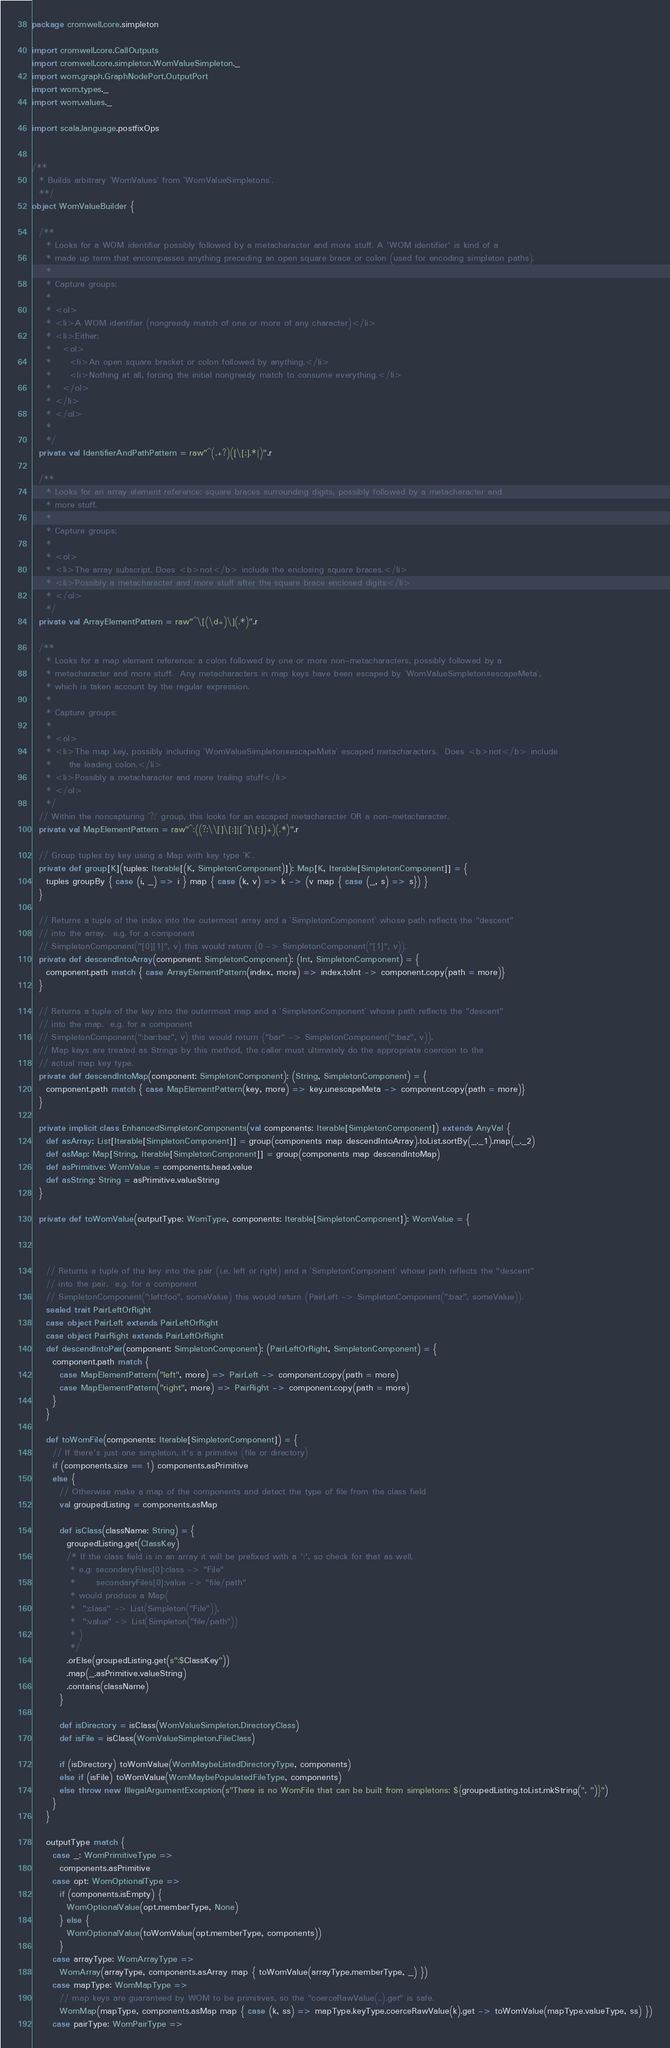<code> <loc_0><loc_0><loc_500><loc_500><_Scala_>package cromwell.core.simpleton

import cromwell.core.CallOutputs
import cromwell.core.simpleton.WomValueSimpleton._
import wom.graph.GraphNodePort.OutputPort
import wom.types._
import wom.values._

import scala.language.postfixOps


/**
  * Builds arbitrary `WomValues` from `WomValueSimpletons`.
  **/
object WomValueBuilder {

  /**
    * Looks for a WOM identifier possibly followed by a metacharacter and more stuff. A 'WOM identifier' is kind of a
    * made up term that encompasses anything preceding an open square brace or colon (used for encoding simpleton paths).
    *
    * Capture groups:
    *
    * <ol>
    * <li>A WOM identifier (nongreedy match of one or more of any character)</li>
    * <li>Either:
    *   <ol>
    *     <li>An open square bracket or colon followed by anything.</li>
    *     <li>Nothing at all, forcing the initial nongreedy match to consume everything.</li>
    *   </ol>
    * </li>
    * </ol>
    *
    */
  private val IdentifierAndPathPattern = raw"^(.+?)([\[:].*|)".r

  /**
    * Looks for an array element reference: square braces surrounding digits, possibly followed by a metacharacter and
    * more stuff.
    *
    * Capture groups:
    *
    * <ol>
    * <li>The array subscript. Does <b>not</b> include the enclosing square braces.</li>
    * <li>Possibly a metacharacter and more stuff after the square brace enclosed digits</li>
    * </ol>
    */
  private val ArrayElementPattern = raw"^\[(\d+)\](.*)".r

  /**
    * Looks for a map element reference: a colon followed by one or more non-metacharacters, possibly followed by a
    * metacharacter and more stuff.  Any metacharacters in map keys have been escaped by `WomValueSimpleton#escapeMeta`,
    * which is taken account by the regular expression.
    *
    * Capture groups:
    *
    * <ol>
    * <li>The map key, possibly including `WomValueSimpleton#escapeMeta` escaped metacharacters.  Does <b>not</b> include
    *     the leading colon.</li>
    * <li>Possibly a metacharacter and more trailing stuff</li>
    * </ol>
    */
  // Within the noncapturing `?:` group, this looks for an escaped metacharacter OR a non-metacharacter.
  private val MapElementPattern = raw"^:((?:\\[]\[:]|[^]\[:])+)(.*)".r

  // Group tuples by key using a Map with key type `K`.
  private def group[K](tuples: Iterable[(K, SimpletonComponent)]): Map[K, Iterable[SimpletonComponent]] = {
    tuples groupBy { case (i, _) => i } map { case (k, v) => k -> (v map { case (_, s) => s}) }
  }

  // Returns a tuple of the index into the outermost array and a `SimpletonComponent` whose path reflects the "descent"
  // into the array.  e.g. for a component
  // SimpletonComponent("[0][1]", v) this would return (0 -> SimpletonComponent("[1]", v)).
  private def descendIntoArray(component: SimpletonComponent): (Int, SimpletonComponent) = {
    component.path match { case ArrayElementPattern(index, more) => index.toInt -> component.copy(path = more)}
  }

  // Returns a tuple of the key into the outermost map and a `SimpletonComponent` whose path reflects the "descent"
  // into the map.  e.g. for a component
  // SimpletonComponent(":bar:baz", v) this would return ("bar" -> SimpletonComponent(":baz", v)).
  // Map keys are treated as Strings by this method, the caller must ultimately do the appropriate coercion to the
  // actual map key type.
  private def descendIntoMap(component: SimpletonComponent): (String, SimpletonComponent) = {
    component.path match { case MapElementPattern(key, more) => key.unescapeMeta -> component.copy(path = more)}
  }

  private implicit class EnhancedSimpletonComponents(val components: Iterable[SimpletonComponent]) extends AnyVal {
    def asArray: List[Iterable[SimpletonComponent]] = group(components map descendIntoArray).toList.sortBy(_._1).map(_._2)
    def asMap: Map[String, Iterable[SimpletonComponent]] = group(components map descendIntoMap)
    def asPrimitive: WomValue = components.head.value
    def asString: String = asPrimitive.valueString
  }

  private def toWomValue(outputType: WomType, components: Iterable[SimpletonComponent]): WomValue = {



    // Returns a tuple of the key into the pair (i.e. left or right) and a `SimpletonComponent` whose path reflects the "descent"
    // into the pair.  e.g. for a component
    // SimpletonComponent(":left:foo", someValue) this would return (PairLeft -> SimpletonComponent(":baz", someValue)).
    sealed trait PairLeftOrRight
    case object PairLeft extends PairLeftOrRight
    case object PairRight extends PairLeftOrRight
    def descendIntoPair(component: SimpletonComponent): (PairLeftOrRight, SimpletonComponent) = {
      component.path match {
        case MapElementPattern("left", more) => PairLeft -> component.copy(path = more)
        case MapElementPattern("right", more) => PairRight -> component.copy(path = more)
      }
    }

    def toWomFile(components: Iterable[SimpletonComponent]) = {
      // If there's just one simpleton, it's a primitive (file or directory)
      if (components.size == 1) components.asPrimitive
      else {
        // Otherwise make a map of the components and detect the type of file from the class field
        val groupedListing = components.asMap

        def isClass(className: String) = {
          groupedListing.get(ClassKey)
          /* If the class field is in an array it will be prefixed with a ':', so check for that as well.
           * e.g: secondaryFiles[0]:class -> "File"
           *      secondaryFiles[0]:value -> "file/path"
           * would produce a Map(
           *  ":class" -> List(Simpleton("File")),
           *  ":value" -> List(Simpleton("file/path"))
           * )
           */
          .orElse(groupedListing.get(s":$ClassKey"))
          .map(_.asPrimitive.valueString)
          .contains(className)
        }

        def isDirectory = isClass(WomValueSimpleton.DirectoryClass)
        def isFile = isClass(WomValueSimpleton.FileClass)

        if (isDirectory) toWomValue(WomMaybeListedDirectoryType, components)
        else if (isFile) toWomValue(WomMaybePopulatedFileType, components)
        else throw new IllegalArgumentException(s"There is no WomFile that can be built from simpletons: ${groupedListing.toList.mkString(", ")}")
      }
    }

    outputType match {
      case _: WomPrimitiveType =>
        components.asPrimitive
      case opt: WomOptionalType =>
        if (components.isEmpty) {
          WomOptionalValue(opt.memberType, None)
        } else {
          WomOptionalValue(toWomValue(opt.memberType, components))
        }
      case arrayType: WomArrayType =>
        WomArray(arrayType, components.asArray map { toWomValue(arrayType.memberType, _) })
      case mapType: WomMapType =>
        // map keys are guaranteed by WOM to be primitives, so the "coerceRawValue(..).get" is safe.
        WomMap(mapType, components.asMap map { case (k, ss) => mapType.keyType.coerceRawValue(k).get -> toWomValue(mapType.valueType, ss) })
      case pairType: WomPairType =></code> 